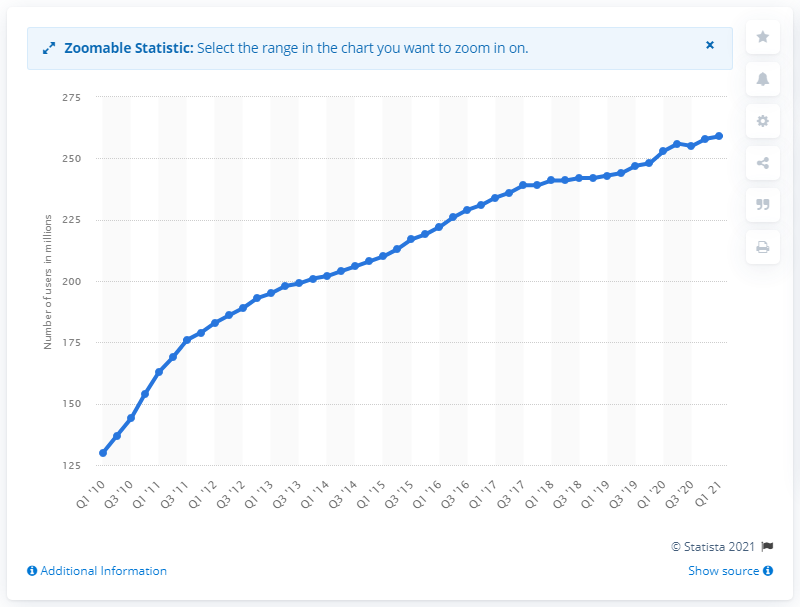Draw attention to some important aspects in this diagram. In the first quarter of 2021, Facebook had approximately 259 million users. 